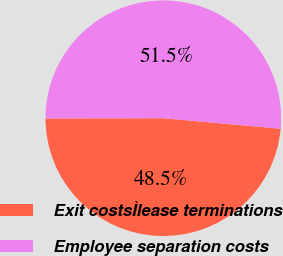Convert chart. <chart><loc_0><loc_0><loc_500><loc_500><pie_chart><fcel>Exit costsÌlease terminations<fcel>Employee separation costs<nl><fcel>48.54%<fcel>51.46%<nl></chart> 